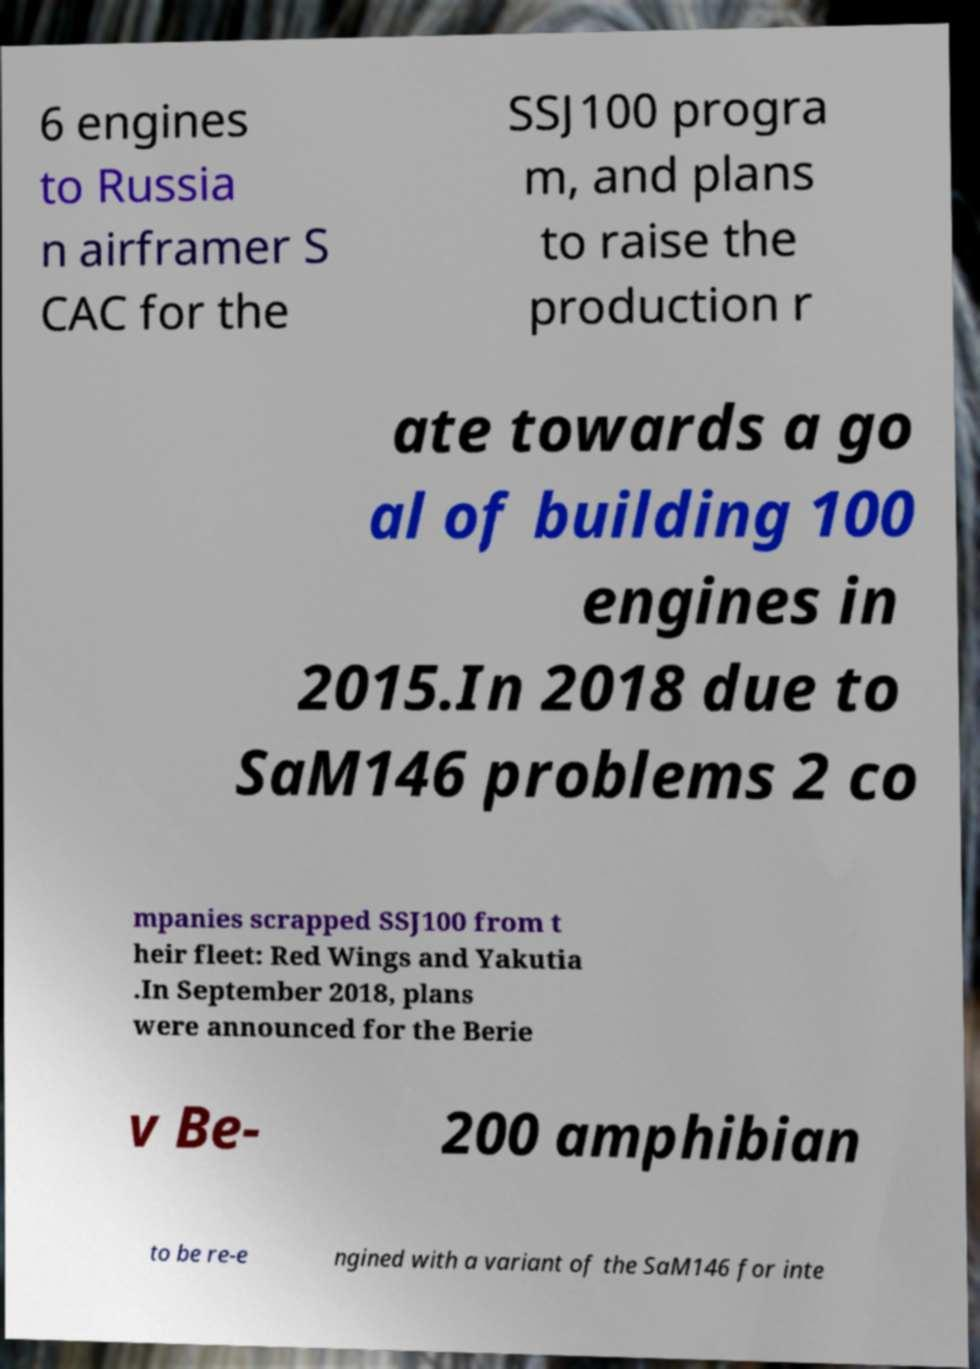There's text embedded in this image that I need extracted. Can you transcribe it verbatim? 6 engines to Russia n airframer S CAC for the SSJ100 progra m, and plans to raise the production r ate towards a go al of building 100 engines in 2015.In 2018 due to SaM146 problems 2 co mpanies scrapped SSJ100 from t heir fleet: Red Wings and Yakutia .In September 2018, plans were announced for the Berie v Be- 200 amphibian to be re-e ngined with a variant of the SaM146 for inte 